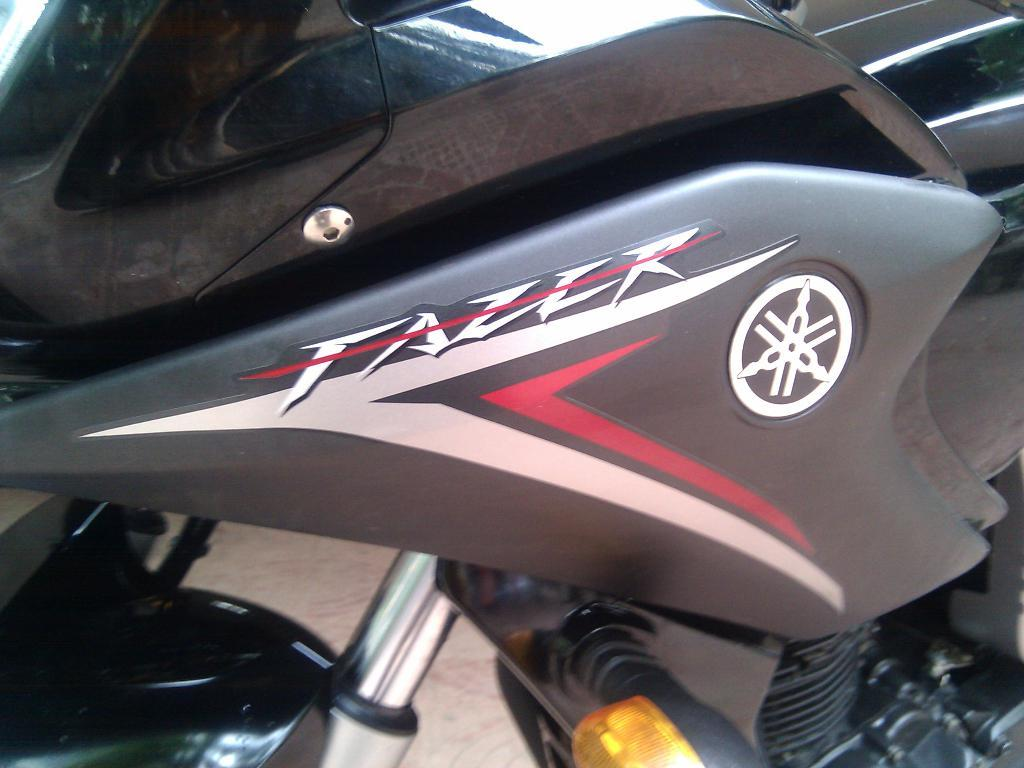What is the main object in the image? There is a bike in the image. What type of glue is used to hold the bike together in the image? There is no mention of glue or any specific materials used to hold the bike together in the image. 